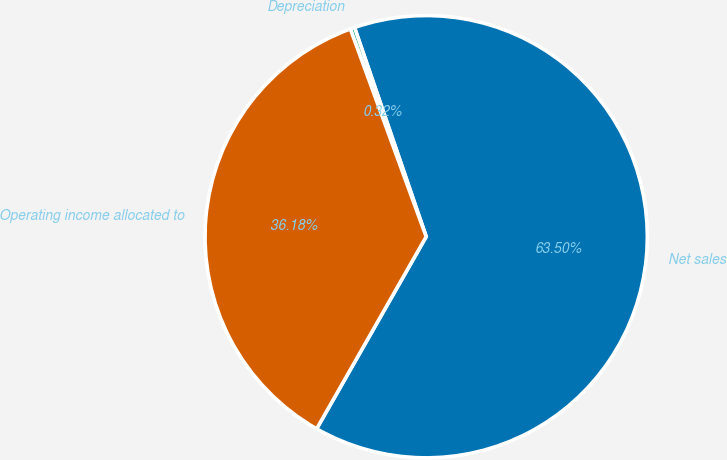Convert chart to OTSL. <chart><loc_0><loc_0><loc_500><loc_500><pie_chart><fcel>Net sales<fcel>Depreciation<fcel>Operating income allocated to<nl><fcel>63.5%<fcel>0.32%<fcel>36.18%<nl></chart> 